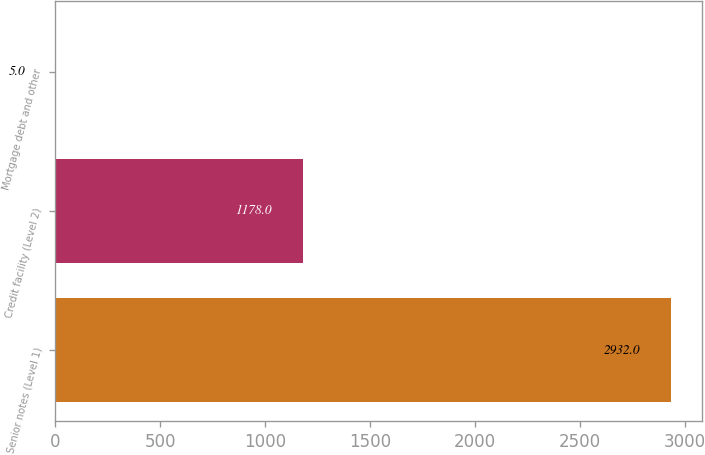Convert chart to OTSL. <chart><loc_0><loc_0><loc_500><loc_500><bar_chart><fcel>Senior notes (Level 1)<fcel>Credit facility (Level 2)<fcel>Mortgage debt and other<nl><fcel>2932<fcel>1178<fcel>5<nl></chart> 